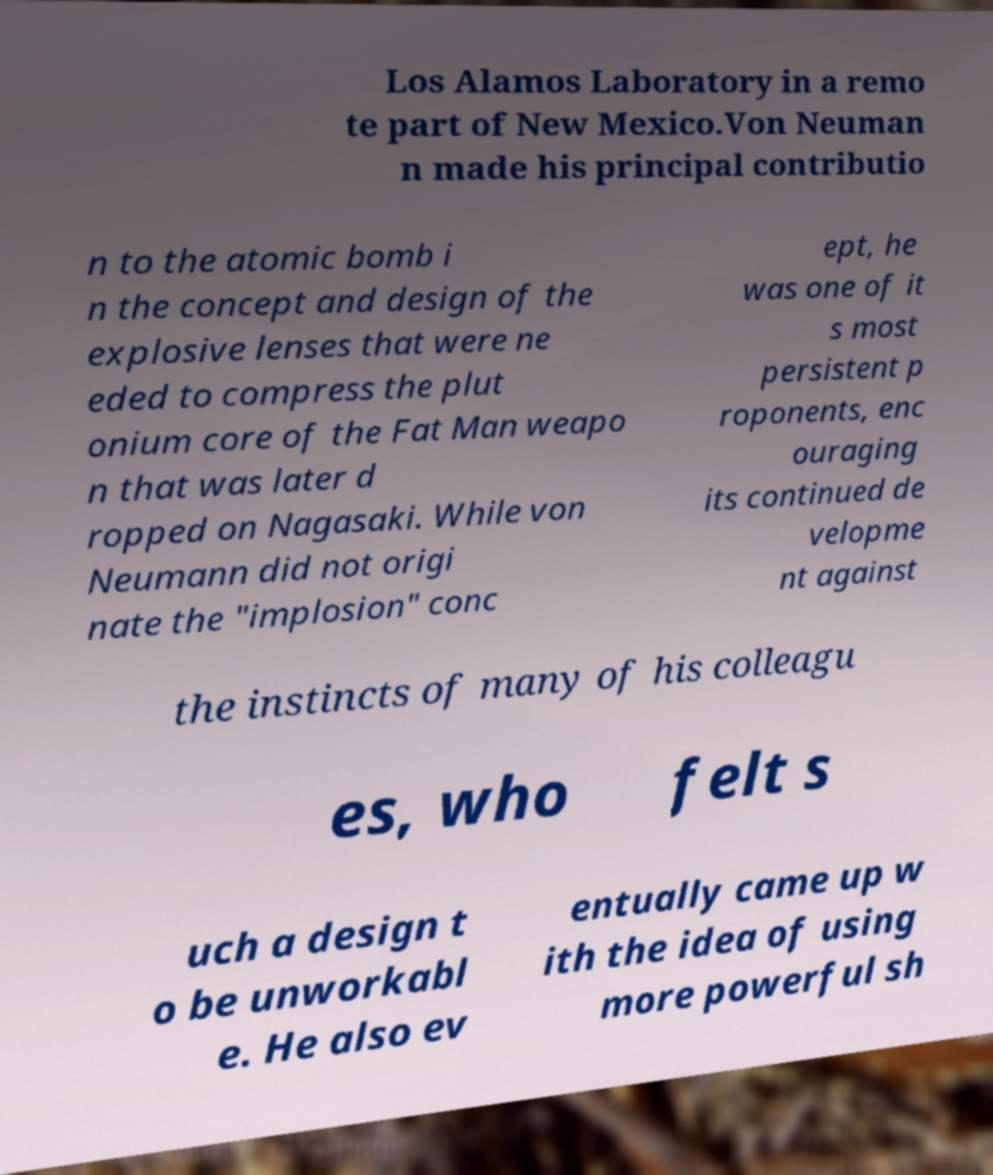Could you assist in decoding the text presented in this image and type it out clearly? Los Alamos Laboratory in a remo te part of New Mexico.Von Neuman n made his principal contributio n to the atomic bomb i n the concept and design of the explosive lenses that were ne eded to compress the plut onium core of the Fat Man weapo n that was later d ropped on Nagasaki. While von Neumann did not origi nate the "implosion" conc ept, he was one of it s most persistent p roponents, enc ouraging its continued de velopme nt against the instincts of many of his colleagu es, who felt s uch a design t o be unworkabl e. He also ev entually came up w ith the idea of using more powerful sh 